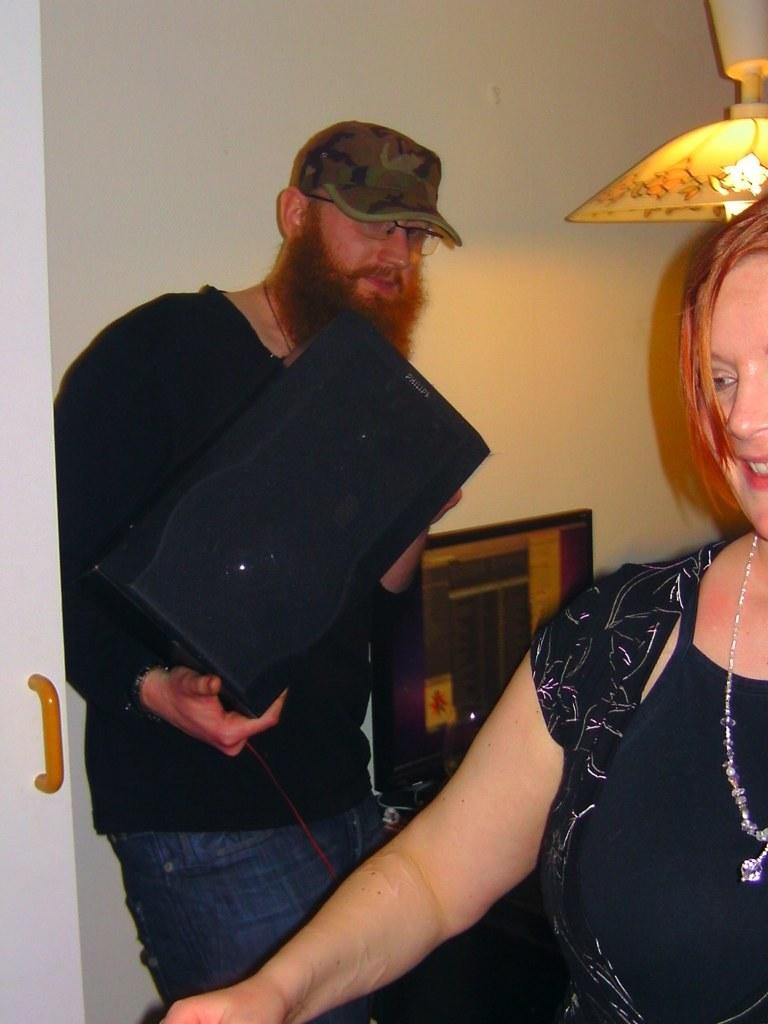How many people are present in the image? There is a man and a woman present in the image. What is the man holding in his hands? The man is holding an object in his hands. What can be seen in the background of the image? There is a wall, a door, a light lamp, and other objects visible in the background of the image. Can you describe the setting where the man and woman are located? The man and woman are located in a room with a wall, a door, and a light lamp in the background. What type of slip is the maid wearing in the image? There is no maid or slip present in the image. 